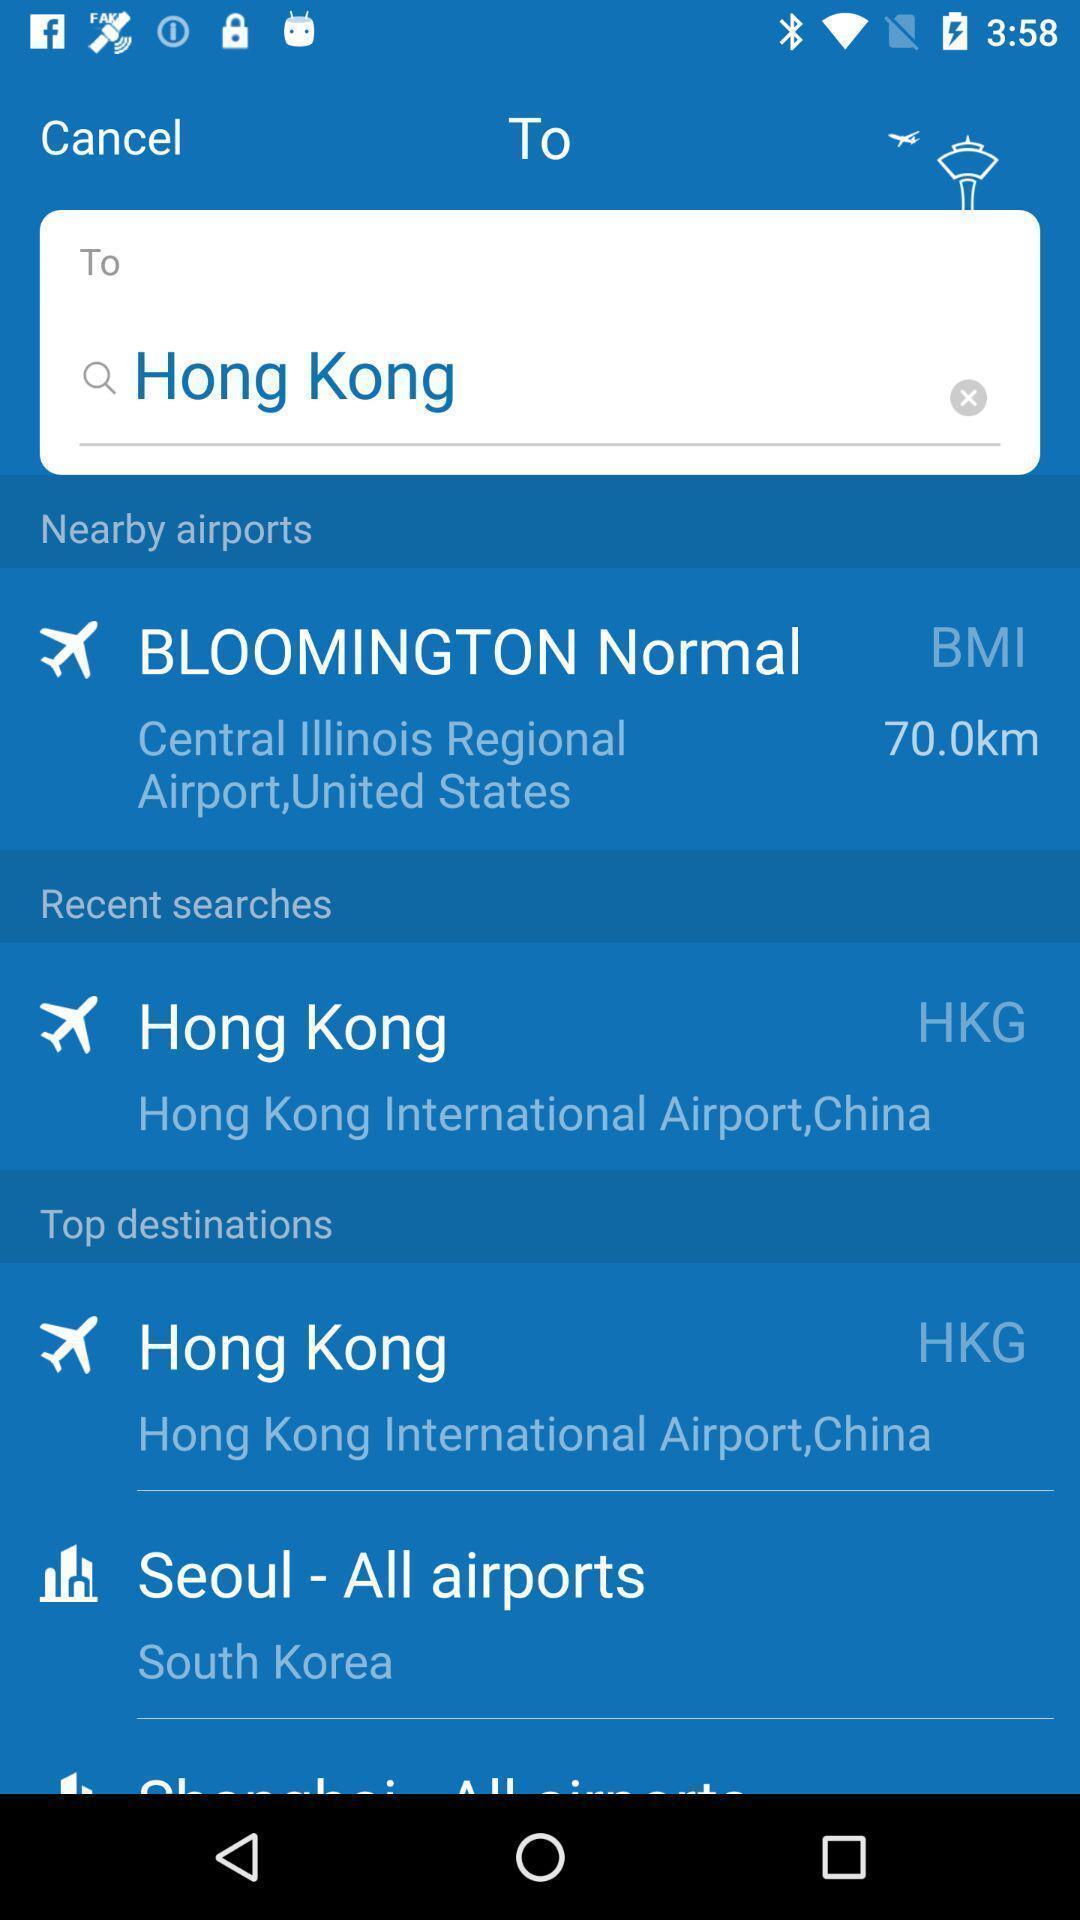What is the overall content of this screenshot? Search page for searching destination of flights in booking app. 